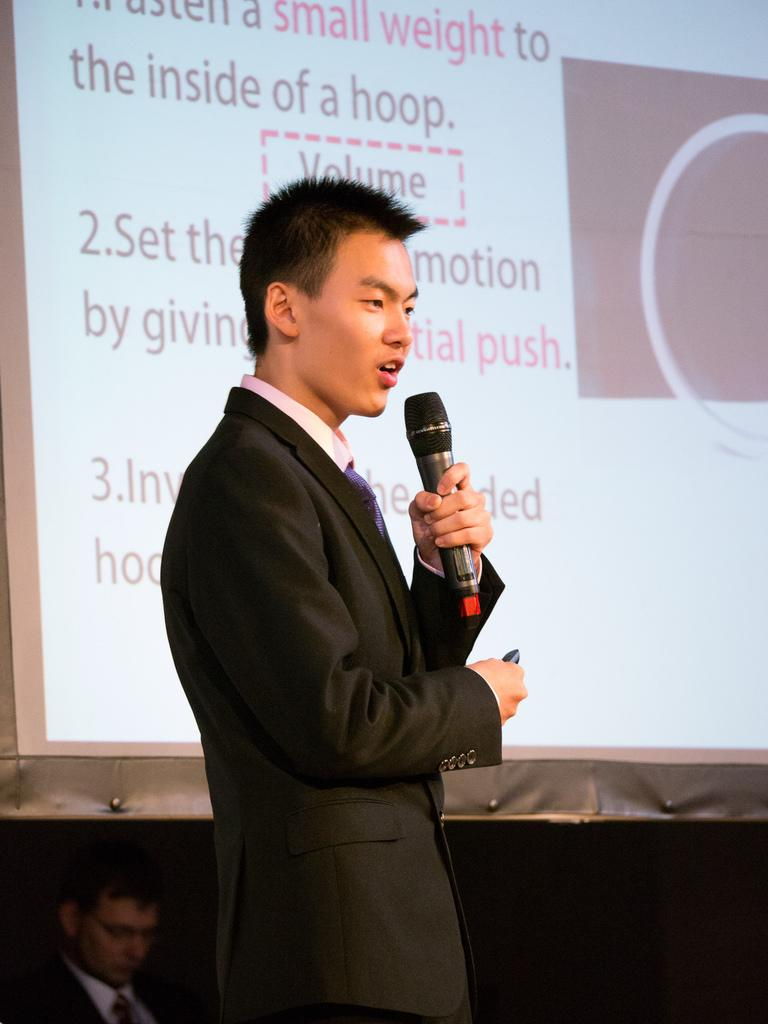What is the main subject of the picture? The main subject of the picture is a man. What is the man doing in the image? The man is standing and speaking in the image. What is the man holding in his left hand? The man is holding a microphone in his left hand. What can be seen in the background of the image? There is a screen in the background of the image. What type of drug can be seen in the man's hand in the image? There is no drug present in the image; the man is holding a microphone in his left hand. How many ducks are visible in the image? There are no ducks present in the image. 